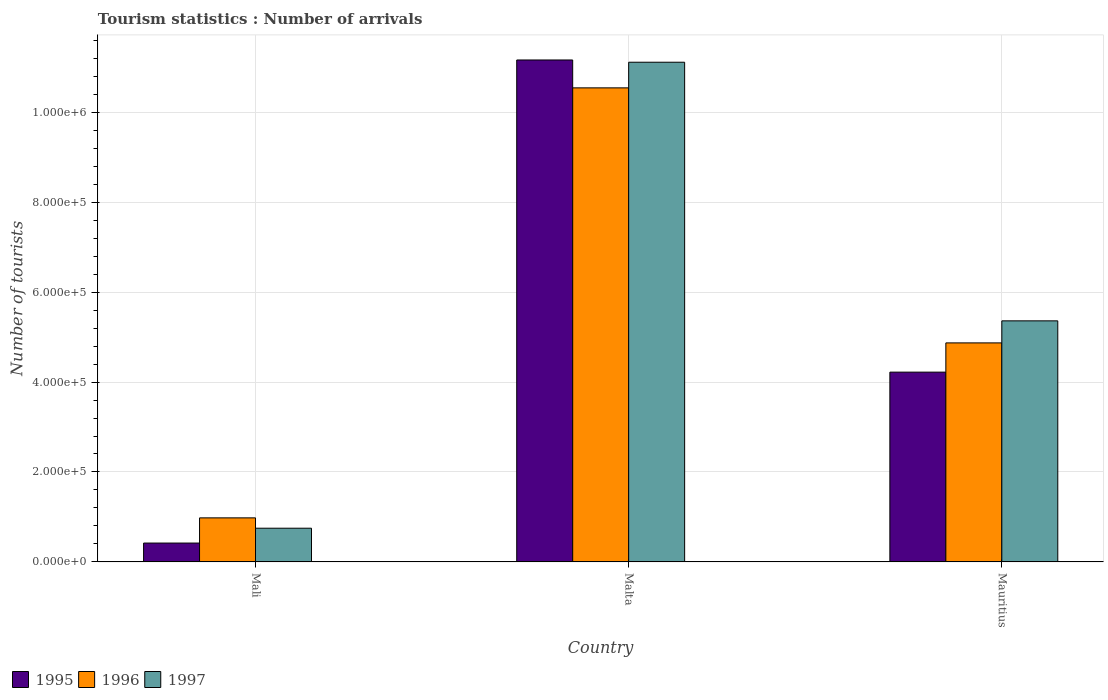Are the number of bars per tick equal to the number of legend labels?
Provide a succinct answer. Yes. How many bars are there on the 2nd tick from the right?
Offer a terse response. 3. What is the label of the 1st group of bars from the left?
Provide a short and direct response. Mali. What is the number of tourist arrivals in 1995 in Mali?
Offer a very short reply. 4.20e+04. Across all countries, what is the maximum number of tourist arrivals in 1995?
Give a very brief answer. 1.12e+06. Across all countries, what is the minimum number of tourist arrivals in 1997?
Your answer should be compact. 7.50e+04. In which country was the number of tourist arrivals in 1997 maximum?
Provide a succinct answer. Malta. In which country was the number of tourist arrivals in 1996 minimum?
Give a very brief answer. Mali. What is the total number of tourist arrivals in 1996 in the graph?
Offer a terse response. 1.64e+06. What is the difference between the number of tourist arrivals in 1997 in Mali and that in Malta?
Your answer should be very brief. -1.04e+06. What is the difference between the number of tourist arrivals in 1996 in Malta and the number of tourist arrivals in 1995 in Mali?
Offer a terse response. 1.01e+06. What is the average number of tourist arrivals in 1997 per country?
Ensure brevity in your answer.  5.74e+05. What is the difference between the number of tourist arrivals of/in 1995 and number of tourist arrivals of/in 1996 in Mali?
Your answer should be very brief. -5.60e+04. What is the ratio of the number of tourist arrivals in 1996 in Mali to that in Malta?
Provide a succinct answer. 0.09. What is the difference between the highest and the second highest number of tourist arrivals in 1997?
Provide a succinct answer. 1.04e+06. What is the difference between the highest and the lowest number of tourist arrivals in 1996?
Offer a very short reply. 9.56e+05. What does the 2nd bar from the right in Mali represents?
Provide a succinct answer. 1996. Is it the case that in every country, the sum of the number of tourist arrivals in 1995 and number of tourist arrivals in 1996 is greater than the number of tourist arrivals in 1997?
Your response must be concise. Yes. How many bars are there?
Your response must be concise. 9. What is the difference between two consecutive major ticks on the Y-axis?
Your answer should be compact. 2.00e+05. Does the graph contain grids?
Provide a short and direct response. Yes. Where does the legend appear in the graph?
Your answer should be compact. Bottom left. What is the title of the graph?
Offer a terse response. Tourism statistics : Number of arrivals. Does "1992" appear as one of the legend labels in the graph?
Provide a short and direct response. No. What is the label or title of the Y-axis?
Ensure brevity in your answer.  Number of tourists. What is the Number of tourists of 1995 in Mali?
Offer a terse response. 4.20e+04. What is the Number of tourists in 1996 in Mali?
Provide a succinct answer. 9.80e+04. What is the Number of tourists of 1997 in Mali?
Offer a terse response. 7.50e+04. What is the Number of tourists in 1995 in Malta?
Your response must be concise. 1.12e+06. What is the Number of tourists in 1996 in Malta?
Give a very brief answer. 1.05e+06. What is the Number of tourists of 1997 in Malta?
Your response must be concise. 1.11e+06. What is the Number of tourists of 1995 in Mauritius?
Offer a very short reply. 4.22e+05. What is the Number of tourists in 1996 in Mauritius?
Offer a very short reply. 4.87e+05. What is the Number of tourists in 1997 in Mauritius?
Offer a terse response. 5.36e+05. Across all countries, what is the maximum Number of tourists of 1995?
Provide a succinct answer. 1.12e+06. Across all countries, what is the maximum Number of tourists of 1996?
Provide a short and direct response. 1.05e+06. Across all countries, what is the maximum Number of tourists in 1997?
Give a very brief answer. 1.11e+06. Across all countries, what is the minimum Number of tourists in 1995?
Your response must be concise. 4.20e+04. Across all countries, what is the minimum Number of tourists of 1996?
Give a very brief answer. 9.80e+04. Across all countries, what is the minimum Number of tourists in 1997?
Provide a short and direct response. 7.50e+04. What is the total Number of tourists in 1995 in the graph?
Keep it short and to the point. 1.58e+06. What is the total Number of tourists of 1996 in the graph?
Offer a terse response. 1.64e+06. What is the total Number of tourists in 1997 in the graph?
Ensure brevity in your answer.  1.72e+06. What is the difference between the Number of tourists in 1995 in Mali and that in Malta?
Offer a terse response. -1.07e+06. What is the difference between the Number of tourists in 1996 in Mali and that in Malta?
Make the answer very short. -9.56e+05. What is the difference between the Number of tourists in 1997 in Mali and that in Malta?
Provide a succinct answer. -1.04e+06. What is the difference between the Number of tourists of 1995 in Mali and that in Mauritius?
Offer a very short reply. -3.80e+05. What is the difference between the Number of tourists of 1996 in Mali and that in Mauritius?
Provide a short and direct response. -3.89e+05. What is the difference between the Number of tourists in 1997 in Mali and that in Mauritius?
Your response must be concise. -4.61e+05. What is the difference between the Number of tourists of 1995 in Malta and that in Mauritius?
Your answer should be compact. 6.94e+05. What is the difference between the Number of tourists in 1996 in Malta and that in Mauritius?
Keep it short and to the point. 5.67e+05. What is the difference between the Number of tourists in 1997 in Malta and that in Mauritius?
Your answer should be compact. 5.75e+05. What is the difference between the Number of tourists in 1995 in Mali and the Number of tourists in 1996 in Malta?
Give a very brief answer. -1.01e+06. What is the difference between the Number of tourists in 1995 in Mali and the Number of tourists in 1997 in Malta?
Keep it short and to the point. -1.07e+06. What is the difference between the Number of tourists in 1996 in Mali and the Number of tourists in 1997 in Malta?
Offer a terse response. -1.01e+06. What is the difference between the Number of tourists in 1995 in Mali and the Number of tourists in 1996 in Mauritius?
Keep it short and to the point. -4.45e+05. What is the difference between the Number of tourists in 1995 in Mali and the Number of tourists in 1997 in Mauritius?
Your answer should be compact. -4.94e+05. What is the difference between the Number of tourists in 1996 in Mali and the Number of tourists in 1997 in Mauritius?
Offer a terse response. -4.38e+05. What is the difference between the Number of tourists in 1995 in Malta and the Number of tourists in 1996 in Mauritius?
Offer a terse response. 6.29e+05. What is the difference between the Number of tourists in 1995 in Malta and the Number of tourists in 1997 in Mauritius?
Make the answer very short. 5.80e+05. What is the difference between the Number of tourists in 1996 in Malta and the Number of tourists in 1997 in Mauritius?
Keep it short and to the point. 5.18e+05. What is the average Number of tourists of 1995 per country?
Ensure brevity in your answer.  5.27e+05. What is the average Number of tourists in 1996 per country?
Your answer should be compact. 5.46e+05. What is the average Number of tourists in 1997 per country?
Offer a terse response. 5.74e+05. What is the difference between the Number of tourists in 1995 and Number of tourists in 1996 in Mali?
Keep it short and to the point. -5.60e+04. What is the difference between the Number of tourists of 1995 and Number of tourists of 1997 in Mali?
Give a very brief answer. -3.30e+04. What is the difference between the Number of tourists in 1996 and Number of tourists in 1997 in Mali?
Give a very brief answer. 2.30e+04. What is the difference between the Number of tourists in 1995 and Number of tourists in 1996 in Malta?
Make the answer very short. 6.20e+04. What is the difference between the Number of tourists of 1996 and Number of tourists of 1997 in Malta?
Provide a short and direct response. -5.70e+04. What is the difference between the Number of tourists of 1995 and Number of tourists of 1996 in Mauritius?
Ensure brevity in your answer.  -6.50e+04. What is the difference between the Number of tourists of 1995 and Number of tourists of 1997 in Mauritius?
Provide a succinct answer. -1.14e+05. What is the difference between the Number of tourists in 1996 and Number of tourists in 1997 in Mauritius?
Ensure brevity in your answer.  -4.90e+04. What is the ratio of the Number of tourists of 1995 in Mali to that in Malta?
Provide a succinct answer. 0.04. What is the ratio of the Number of tourists in 1996 in Mali to that in Malta?
Your response must be concise. 0.09. What is the ratio of the Number of tourists in 1997 in Mali to that in Malta?
Make the answer very short. 0.07. What is the ratio of the Number of tourists of 1995 in Mali to that in Mauritius?
Make the answer very short. 0.1. What is the ratio of the Number of tourists in 1996 in Mali to that in Mauritius?
Your response must be concise. 0.2. What is the ratio of the Number of tourists in 1997 in Mali to that in Mauritius?
Provide a short and direct response. 0.14. What is the ratio of the Number of tourists of 1995 in Malta to that in Mauritius?
Make the answer very short. 2.64. What is the ratio of the Number of tourists in 1996 in Malta to that in Mauritius?
Your answer should be very brief. 2.16. What is the ratio of the Number of tourists in 1997 in Malta to that in Mauritius?
Make the answer very short. 2.07. What is the difference between the highest and the second highest Number of tourists in 1995?
Give a very brief answer. 6.94e+05. What is the difference between the highest and the second highest Number of tourists in 1996?
Offer a terse response. 5.67e+05. What is the difference between the highest and the second highest Number of tourists in 1997?
Provide a succinct answer. 5.75e+05. What is the difference between the highest and the lowest Number of tourists in 1995?
Your answer should be compact. 1.07e+06. What is the difference between the highest and the lowest Number of tourists in 1996?
Offer a terse response. 9.56e+05. What is the difference between the highest and the lowest Number of tourists in 1997?
Provide a short and direct response. 1.04e+06. 